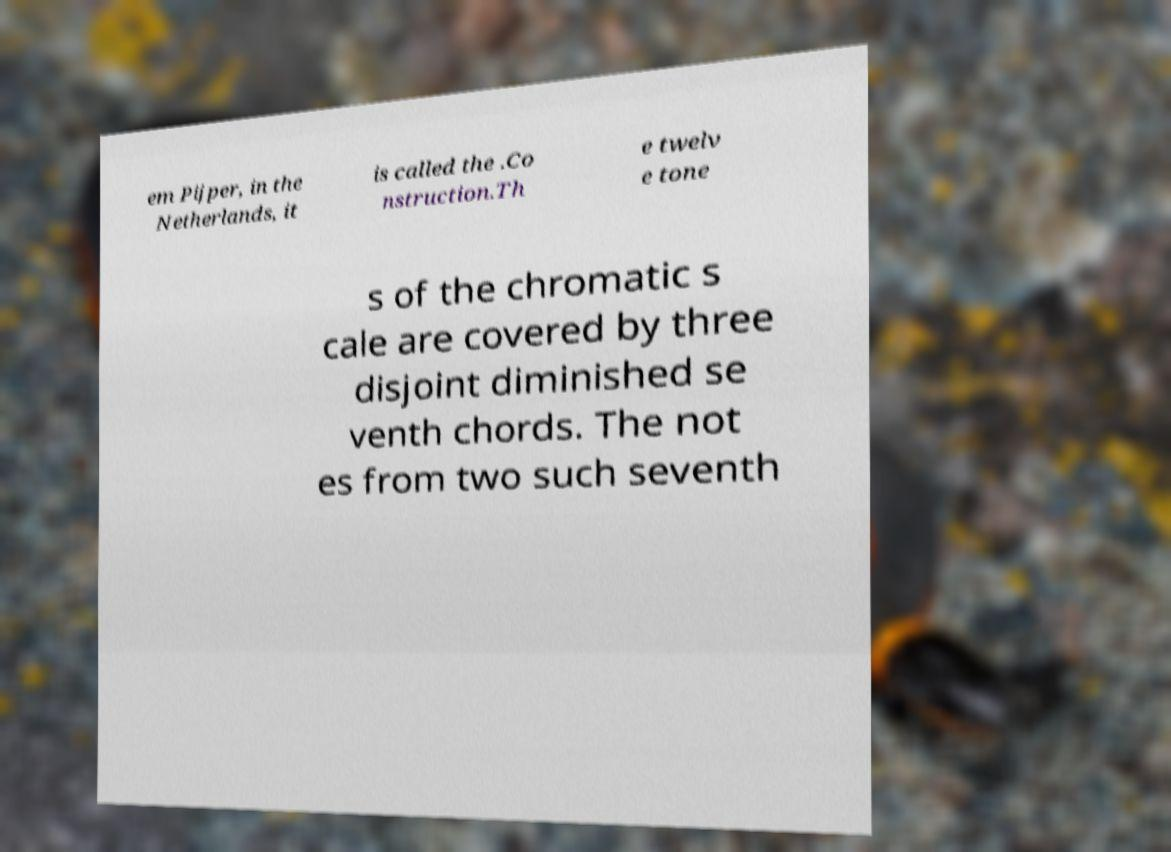There's text embedded in this image that I need extracted. Can you transcribe it verbatim? em Pijper, in the Netherlands, it is called the .Co nstruction.Th e twelv e tone s of the chromatic s cale are covered by three disjoint diminished se venth chords. The not es from two such seventh 